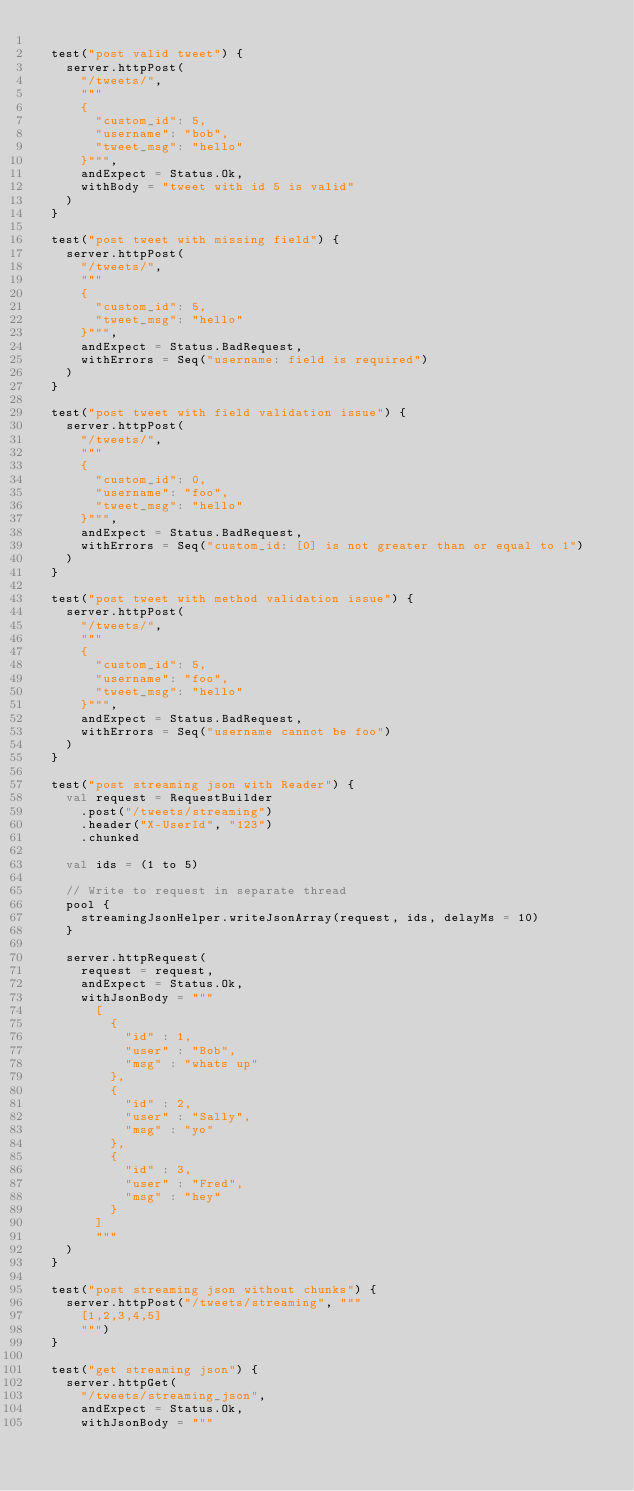Convert code to text. <code><loc_0><loc_0><loc_500><loc_500><_Scala_>
  test("post valid tweet") {
    server.httpPost(
      "/tweets/",
      """
      {
        "custom_id": 5,
        "username": "bob",
        "tweet_msg": "hello"
      }""",
      andExpect = Status.Ok,
      withBody = "tweet with id 5 is valid"
    )
  }

  test("post tweet with missing field") {
    server.httpPost(
      "/tweets/",
      """
      {
        "custom_id": 5,
        "tweet_msg": "hello"
      }""",
      andExpect = Status.BadRequest,
      withErrors = Seq("username: field is required")
    )
  }

  test("post tweet with field validation issue") {
    server.httpPost(
      "/tweets/",
      """
      {
        "custom_id": 0,
        "username": "foo",
        "tweet_msg": "hello"
      }""",
      andExpect = Status.BadRequest,
      withErrors = Seq("custom_id: [0] is not greater than or equal to 1")
    )
  }

  test("post tweet with method validation issue") {
    server.httpPost(
      "/tweets/",
      """
      {
        "custom_id": 5,
        "username": "foo",
        "tweet_msg": "hello"
      }""",
      andExpect = Status.BadRequest,
      withErrors = Seq("username cannot be foo")
    )
  }

  test("post streaming json with Reader") {
    val request = RequestBuilder
      .post("/tweets/streaming")
      .header("X-UserId", "123")
      .chunked

    val ids = (1 to 5)

    // Write to request in separate thread
    pool {
      streamingJsonHelper.writeJsonArray(request, ids, delayMs = 10)
    }

    server.httpRequest(
      request = request,
      andExpect = Status.Ok,
      withJsonBody = """
        [
          {
            "id" : 1,
            "user" : "Bob",
            "msg" : "whats up"
          },
          {
            "id" : 2,
            "user" : "Sally",
            "msg" : "yo"
          },
          {
            "id" : 3,
            "user" : "Fred",
            "msg" : "hey"
          }
        ]
        """
    )
  }

  test("post streaming json without chunks") {
    server.httpPost("/tweets/streaming", """
      [1,2,3,4,5]
      """)
  }

  test("get streaming json") {
    server.httpGet(
      "/tweets/streaming_json",
      andExpect = Status.Ok,
      withJsonBody = """</code> 